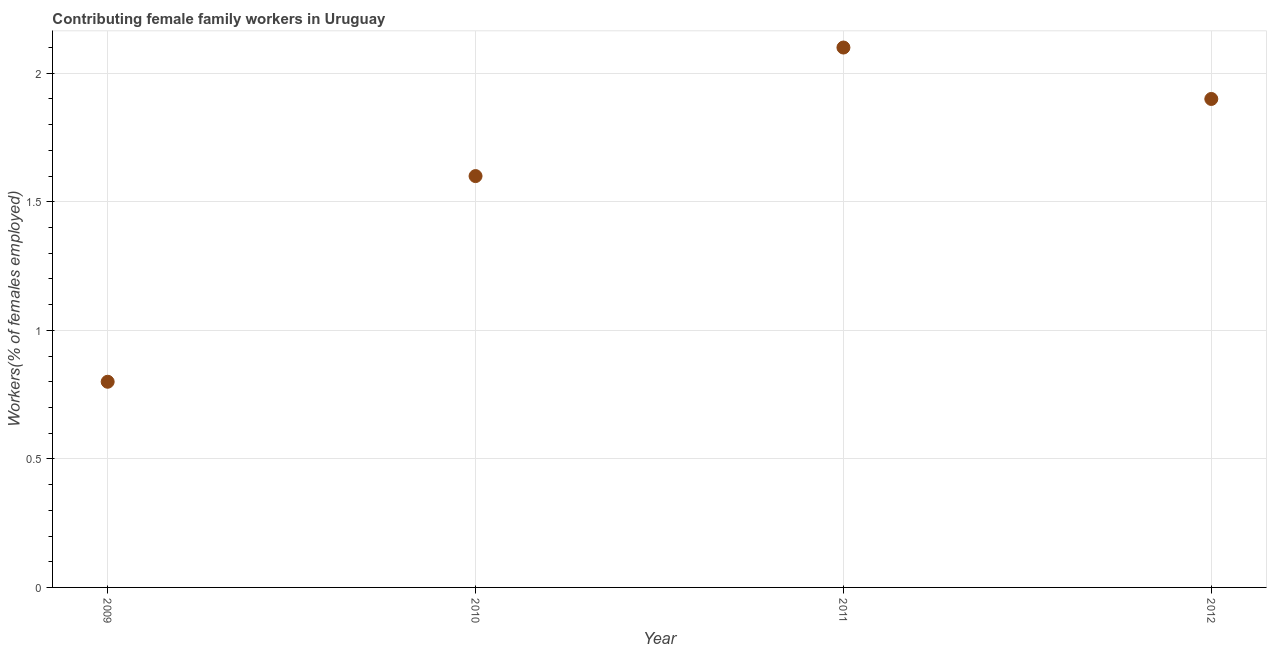What is the contributing female family workers in 2011?
Give a very brief answer. 2.1. Across all years, what is the maximum contributing female family workers?
Provide a succinct answer. 2.1. Across all years, what is the minimum contributing female family workers?
Offer a terse response. 0.8. What is the sum of the contributing female family workers?
Offer a terse response. 6.4. What is the difference between the contributing female family workers in 2009 and 2010?
Ensure brevity in your answer.  -0.8. What is the average contributing female family workers per year?
Provide a succinct answer. 1.6. What is the median contributing female family workers?
Ensure brevity in your answer.  1.75. What is the ratio of the contributing female family workers in 2009 to that in 2011?
Ensure brevity in your answer.  0.38. Is the contributing female family workers in 2009 less than that in 2012?
Ensure brevity in your answer.  Yes. Is the difference between the contributing female family workers in 2009 and 2011 greater than the difference between any two years?
Keep it short and to the point. Yes. What is the difference between the highest and the second highest contributing female family workers?
Your answer should be compact. 0.2. Is the sum of the contributing female family workers in 2009 and 2010 greater than the maximum contributing female family workers across all years?
Your answer should be very brief. Yes. What is the difference between the highest and the lowest contributing female family workers?
Offer a terse response. 1.3. How many dotlines are there?
Keep it short and to the point. 1. How many years are there in the graph?
Your answer should be very brief. 4. What is the difference between two consecutive major ticks on the Y-axis?
Keep it short and to the point. 0.5. What is the title of the graph?
Your answer should be very brief. Contributing female family workers in Uruguay. What is the label or title of the X-axis?
Your answer should be compact. Year. What is the label or title of the Y-axis?
Provide a succinct answer. Workers(% of females employed). What is the Workers(% of females employed) in 2009?
Your answer should be compact. 0.8. What is the Workers(% of females employed) in 2010?
Offer a terse response. 1.6. What is the Workers(% of females employed) in 2011?
Make the answer very short. 2.1. What is the Workers(% of females employed) in 2012?
Your response must be concise. 1.9. What is the difference between the Workers(% of females employed) in 2009 and 2010?
Keep it short and to the point. -0.8. What is the difference between the Workers(% of females employed) in 2009 and 2012?
Give a very brief answer. -1.1. What is the difference between the Workers(% of females employed) in 2010 and 2011?
Your answer should be compact. -0.5. What is the ratio of the Workers(% of females employed) in 2009 to that in 2011?
Your answer should be very brief. 0.38. What is the ratio of the Workers(% of females employed) in 2009 to that in 2012?
Your answer should be very brief. 0.42. What is the ratio of the Workers(% of females employed) in 2010 to that in 2011?
Provide a short and direct response. 0.76. What is the ratio of the Workers(% of females employed) in 2010 to that in 2012?
Your response must be concise. 0.84. What is the ratio of the Workers(% of females employed) in 2011 to that in 2012?
Make the answer very short. 1.1. 